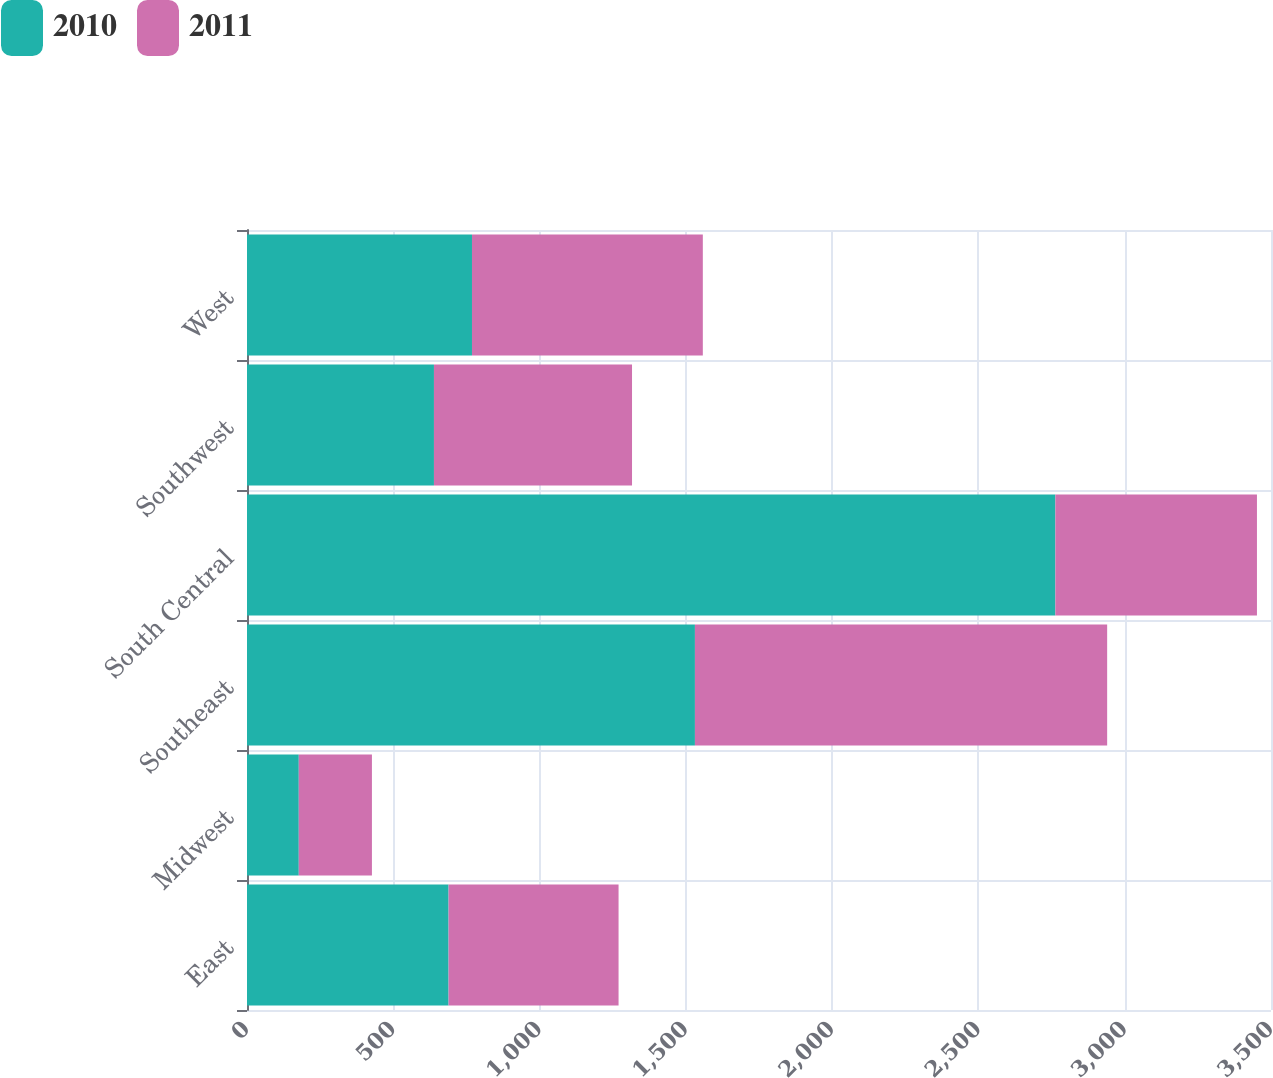<chart> <loc_0><loc_0><loc_500><loc_500><stacked_bar_chart><ecel><fcel>East<fcel>Midwest<fcel>Southeast<fcel>South Central<fcel>Southwest<fcel>West<nl><fcel>2010<fcel>689<fcel>177<fcel>1531<fcel>2763<fcel>639<fcel>769<nl><fcel>2011<fcel>581<fcel>250<fcel>1409<fcel>689<fcel>677<fcel>789<nl></chart> 